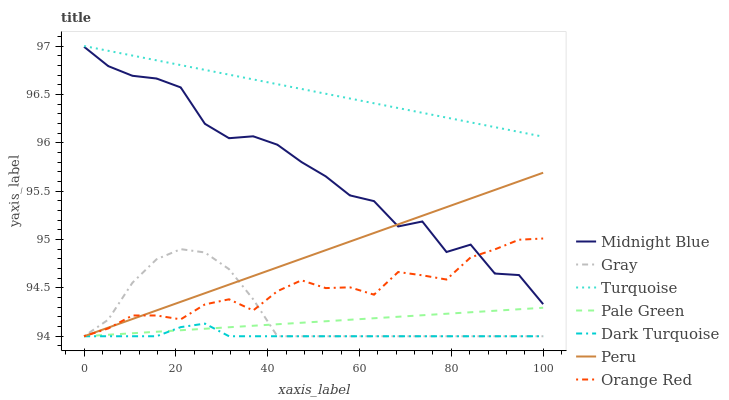Does Midnight Blue have the minimum area under the curve?
Answer yes or no. No. Does Midnight Blue have the maximum area under the curve?
Answer yes or no. No. Is Turquoise the smoothest?
Answer yes or no. No. Is Turquoise the roughest?
Answer yes or no. No. Does Midnight Blue have the lowest value?
Answer yes or no. No. Does Midnight Blue have the highest value?
Answer yes or no. No. Is Gray less than Turquoise?
Answer yes or no. Yes. Is Midnight Blue greater than Pale Green?
Answer yes or no. Yes. Does Gray intersect Turquoise?
Answer yes or no. No. 